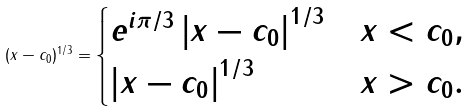Convert formula to latex. <formula><loc_0><loc_0><loc_500><loc_500>( x - c _ { 0 } ) ^ { 1 / 3 } = \begin{cases} e ^ { i \pi / 3 } \left | x - c _ { 0 } \right | ^ { 1 / 3 } & x < c _ { 0 } , \\ \left | x - c _ { 0 } \right | ^ { 1 / 3 } & x > c _ { 0 } . \end{cases}</formula> 